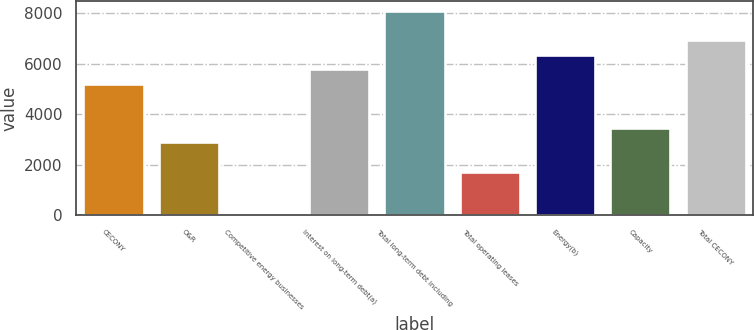<chart> <loc_0><loc_0><loc_500><loc_500><bar_chart><fcel>CECONY<fcel>O&R<fcel>Competitive energy businesses<fcel>Interest on long-term debt(a)<fcel>Total long-term debt including<fcel>Total operating leases<fcel>Energy(b)<fcel>Capacity<fcel>Total CECONY<nl><fcel>5192.7<fcel>2887.5<fcel>6<fcel>5769<fcel>8074.2<fcel>1734.9<fcel>6345.3<fcel>3463.8<fcel>6921.6<nl></chart> 